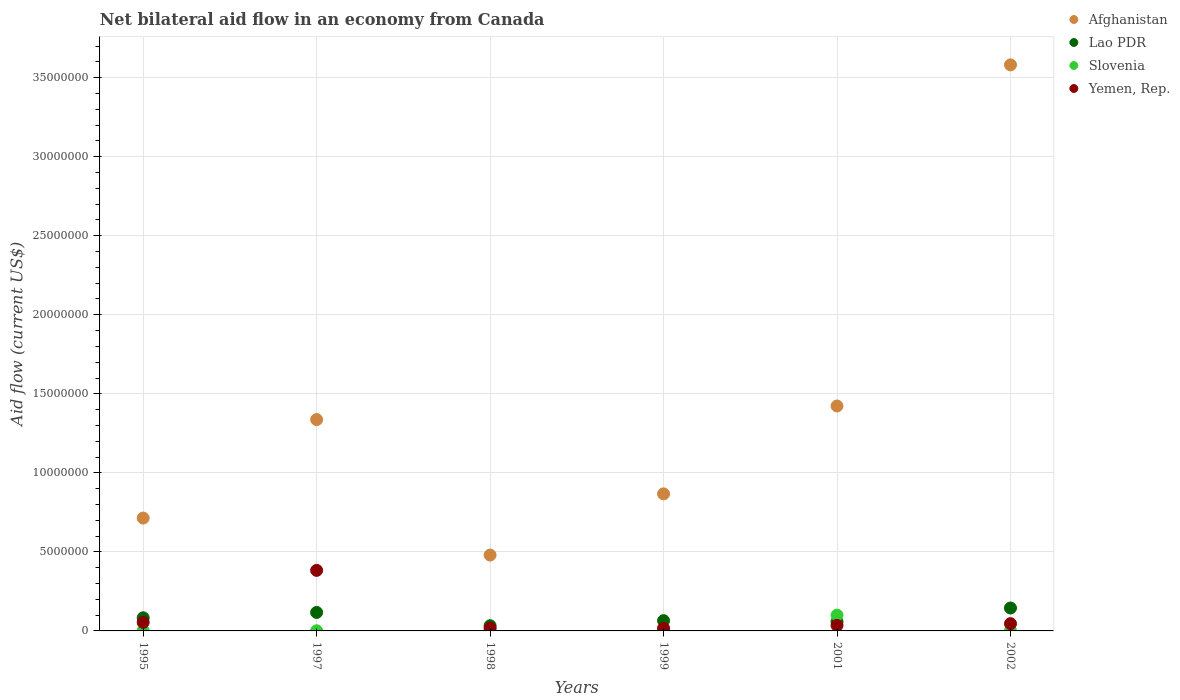How many different coloured dotlines are there?
Give a very brief answer. 4. Is the number of dotlines equal to the number of legend labels?
Your response must be concise. Yes. Across all years, what is the maximum net bilateral aid flow in Yemen, Rep.?
Ensure brevity in your answer.  3.83e+06. What is the total net bilateral aid flow in Afghanistan in the graph?
Offer a terse response. 8.40e+07. What is the difference between the net bilateral aid flow in Lao PDR in 1999 and the net bilateral aid flow in Afghanistan in 2001?
Offer a very short reply. -1.36e+07. What is the average net bilateral aid flow in Lao PDR per year?
Make the answer very short. 8.35e+05. In the year 1997, what is the difference between the net bilateral aid flow in Afghanistan and net bilateral aid flow in Yemen, Rep.?
Ensure brevity in your answer.  9.54e+06. In how many years, is the net bilateral aid flow in Yemen, Rep. greater than 31000000 US$?
Offer a terse response. 0. What is the ratio of the net bilateral aid flow in Lao PDR in 1998 to that in 2002?
Provide a succinct answer. 0.23. Is the net bilateral aid flow in Lao PDR in 1995 less than that in 1999?
Ensure brevity in your answer.  No. Is the difference between the net bilateral aid flow in Afghanistan in 1997 and 1999 greater than the difference between the net bilateral aid flow in Yemen, Rep. in 1997 and 1999?
Your answer should be very brief. Yes. What is the difference between the highest and the second highest net bilateral aid flow in Yemen, Rep.?
Offer a very short reply. 3.29e+06. What is the difference between the highest and the lowest net bilateral aid flow in Yemen, Rep.?
Offer a terse response. 3.66e+06. In how many years, is the net bilateral aid flow in Slovenia greater than the average net bilateral aid flow in Slovenia taken over all years?
Offer a terse response. 1. Is the sum of the net bilateral aid flow in Yemen, Rep. in 1997 and 1998 greater than the maximum net bilateral aid flow in Afghanistan across all years?
Keep it short and to the point. No. Is it the case that in every year, the sum of the net bilateral aid flow in Lao PDR and net bilateral aid flow in Slovenia  is greater than the sum of net bilateral aid flow in Afghanistan and net bilateral aid flow in Yemen, Rep.?
Ensure brevity in your answer.  No. Does the net bilateral aid flow in Yemen, Rep. monotonically increase over the years?
Your answer should be compact. No. Is the net bilateral aid flow in Afghanistan strictly greater than the net bilateral aid flow in Yemen, Rep. over the years?
Your answer should be compact. Yes. Are the values on the major ticks of Y-axis written in scientific E-notation?
Provide a short and direct response. No. Does the graph contain any zero values?
Your response must be concise. No. Does the graph contain grids?
Provide a short and direct response. Yes. Where does the legend appear in the graph?
Keep it short and to the point. Top right. How many legend labels are there?
Make the answer very short. 4. How are the legend labels stacked?
Make the answer very short. Vertical. What is the title of the graph?
Your answer should be compact. Net bilateral aid flow in an economy from Canada. Does "Mexico" appear as one of the legend labels in the graph?
Your response must be concise. No. What is the label or title of the X-axis?
Make the answer very short. Years. What is the label or title of the Y-axis?
Give a very brief answer. Aid flow (current US$). What is the Aid flow (current US$) in Afghanistan in 1995?
Keep it short and to the point. 7.14e+06. What is the Aid flow (current US$) in Lao PDR in 1995?
Provide a succinct answer. 8.30e+05. What is the Aid flow (current US$) in Slovenia in 1995?
Provide a short and direct response. 2.00e+04. What is the Aid flow (current US$) in Yemen, Rep. in 1995?
Ensure brevity in your answer.  5.40e+05. What is the Aid flow (current US$) of Afghanistan in 1997?
Offer a very short reply. 1.34e+07. What is the Aid flow (current US$) in Lao PDR in 1997?
Keep it short and to the point. 1.17e+06. What is the Aid flow (current US$) of Slovenia in 1997?
Make the answer very short. 10000. What is the Aid flow (current US$) in Yemen, Rep. in 1997?
Keep it short and to the point. 3.83e+06. What is the Aid flow (current US$) in Afghanistan in 1998?
Make the answer very short. 4.80e+06. What is the Aid flow (current US$) in Slovenia in 1998?
Your response must be concise. 10000. What is the Aid flow (current US$) of Yemen, Rep. in 1998?
Your response must be concise. 1.80e+05. What is the Aid flow (current US$) in Afghanistan in 1999?
Make the answer very short. 8.67e+06. What is the Aid flow (current US$) in Lao PDR in 1999?
Offer a very short reply. 6.50e+05. What is the Aid flow (current US$) of Slovenia in 1999?
Provide a short and direct response. 2.00e+04. What is the Aid flow (current US$) of Yemen, Rep. in 1999?
Offer a terse response. 1.70e+05. What is the Aid flow (current US$) of Afghanistan in 2001?
Your answer should be very brief. 1.42e+07. What is the Aid flow (current US$) of Lao PDR in 2001?
Keep it short and to the point. 5.80e+05. What is the Aid flow (current US$) of Afghanistan in 2002?
Your response must be concise. 3.58e+07. What is the Aid flow (current US$) in Lao PDR in 2002?
Ensure brevity in your answer.  1.45e+06. What is the Aid flow (current US$) in Slovenia in 2002?
Make the answer very short. 10000. Across all years, what is the maximum Aid flow (current US$) of Afghanistan?
Make the answer very short. 3.58e+07. Across all years, what is the maximum Aid flow (current US$) of Lao PDR?
Make the answer very short. 1.45e+06. Across all years, what is the maximum Aid flow (current US$) in Yemen, Rep.?
Offer a very short reply. 3.83e+06. Across all years, what is the minimum Aid flow (current US$) in Afghanistan?
Offer a very short reply. 4.80e+06. Across all years, what is the minimum Aid flow (current US$) in Lao PDR?
Offer a terse response. 3.30e+05. What is the total Aid flow (current US$) of Afghanistan in the graph?
Your response must be concise. 8.40e+07. What is the total Aid flow (current US$) in Lao PDR in the graph?
Provide a short and direct response. 5.01e+06. What is the total Aid flow (current US$) of Slovenia in the graph?
Provide a succinct answer. 1.07e+06. What is the total Aid flow (current US$) of Yemen, Rep. in the graph?
Make the answer very short. 5.53e+06. What is the difference between the Aid flow (current US$) in Afghanistan in 1995 and that in 1997?
Provide a short and direct response. -6.23e+06. What is the difference between the Aid flow (current US$) of Lao PDR in 1995 and that in 1997?
Your answer should be very brief. -3.40e+05. What is the difference between the Aid flow (current US$) in Slovenia in 1995 and that in 1997?
Your response must be concise. 10000. What is the difference between the Aid flow (current US$) in Yemen, Rep. in 1995 and that in 1997?
Your response must be concise. -3.29e+06. What is the difference between the Aid flow (current US$) of Afghanistan in 1995 and that in 1998?
Your answer should be compact. 2.34e+06. What is the difference between the Aid flow (current US$) of Lao PDR in 1995 and that in 1998?
Provide a short and direct response. 5.00e+05. What is the difference between the Aid flow (current US$) in Slovenia in 1995 and that in 1998?
Provide a succinct answer. 10000. What is the difference between the Aid flow (current US$) in Yemen, Rep. in 1995 and that in 1998?
Ensure brevity in your answer.  3.60e+05. What is the difference between the Aid flow (current US$) of Afghanistan in 1995 and that in 1999?
Your answer should be very brief. -1.53e+06. What is the difference between the Aid flow (current US$) in Slovenia in 1995 and that in 1999?
Offer a very short reply. 0. What is the difference between the Aid flow (current US$) of Afghanistan in 1995 and that in 2001?
Keep it short and to the point. -7.09e+06. What is the difference between the Aid flow (current US$) of Lao PDR in 1995 and that in 2001?
Give a very brief answer. 2.50e+05. What is the difference between the Aid flow (current US$) in Slovenia in 1995 and that in 2001?
Make the answer very short. -9.80e+05. What is the difference between the Aid flow (current US$) of Afghanistan in 1995 and that in 2002?
Offer a terse response. -2.87e+07. What is the difference between the Aid flow (current US$) in Lao PDR in 1995 and that in 2002?
Provide a short and direct response. -6.20e+05. What is the difference between the Aid flow (current US$) in Slovenia in 1995 and that in 2002?
Keep it short and to the point. 10000. What is the difference between the Aid flow (current US$) in Afghanistan in 1997 and that in 1998?
Ensure brevity in your answer.  8.57e+06. What is the difference between the Aid flow (current US$) of Lao PDR in 1997 and that in 1998?
Provide a short and direct response. 8.40e+05. What is the difference between the Aid flow (current US$) of Yemen, Rep. in 1997 and that in 1998?
Offer a very short reply. 3.65e+06. What is the difference between the Aid flow (current US$) of Afghanistan in 1997 and that in 1999?
Offer a terse response. 4.70e+06. What is the difference between the Aid flow (current US$) of Lao PDR in 1997 and that in 1999?
Give a very brief answer. 5.20e+05. What is the difference between the Aid flow (current US$) in Yemen, Rep. in 1997 and that in 1999?
Your answer should be compact. 3.66e+06. What is the difference between the Aid flow (current US$) of Afghanistan in 1997 and that in 2001?
Provide a succinct answer. -8.60e+05. What is the difference between the Aid flow (current US$) of Lao PDR in 1997 and that in 2001?
Ensure brevity in your answer.  5.90e+05. What is the difference between the Aid flow (current US$) of Slovenia in 1997 and that in 2001?
Ensure brevity in your answer.  -9.90e+05. What is the difference between the Aid flow (current US$) of Yemen, Rep. in 1997 and that in 2001?
Ensure brevity in your answer.  3.48e+06. What is the difference between the Aid flow (current US$) of Afghanistan in 1997 and that in 2002?
Offer a very short reply. -2.24e+07. What is the difference between the Aid flow (current US$) of Lao PDR in 1997 and that in 2002?
Ensure brevity in your answer.  -2.80e+05. What is the difference between the Aid flow (current US$) in Yemen, Rep. in 1997 and that in 2002?
Offer a very short reply. 3.37e+06. What is the difference between the Aid flow (current US$) in Afghanistan in 1998 and that in 1999?
Your response must be concise. -3.87e+06. What is the difference between the Aid flow (current US$) in Lao PDR in 1998 and that in 1999?
Give a very brief answer. -3.20e+05. What is the difference between the Aid flow (current US$) of Yemen, Rep. in 1998 and that in 1999?
Your answer should be very brief. 10000. What is the difference between the Aid flow (current US$) in Afghanistan in 1998 and that in 2001?
Offer a very short reply. -9.43e+06. What is the difference between the Aid flow (current US$) of Slovenia in 1998 and that in 2001?
Make the answer very short. -9.90e+05. What is the difference between the Aid flow (current US$) of Afghanistan in 1998 and that in 2002?
Your response must be concise. -3.10e+07. What is the difference between the Aid flow (current US$) in Lao PDR in 1998 and that in 2002?
Your answer should be very brief. -1.12e+06. What is the difference between the Aid flow (current US$) of Yemen, Rep. in 1998 and that in 2002?
Ensure brevity in your answer.  -2.80e+05. What is the difference between the Aid flow (current US$) in Afghanistan in 1999 and that in 2001?
Offer a very short reply. -5.56e+06. What is the difference between the Aid flow (current US$) in Lao PDR in 1999 and that in 2001?
Your answer should be very brief. 7.00e+04. What is the difference between the Aid flow (current US$) of Slovenia in 1999 and that in 2001?
Provide a succinct answer. -9.80e+05. What is the difference between the Aid flow (current US$) in Yemen, Rep. in 1999 and that in 2001?
Ensure brevity in your answer.  -1.80e+05. What is the difference between the Aid flow (current US$) in Afghanistan in 1999 and that in 2002?
Offer a terse response. -2.71e+07. What is the difference between the Aid flow (current US$) in Lao PDR in 1999 and that in 2002?
Keep it short and to the point. -8.00e+05. What is the difference between the Aid flow (current US$) in Afghanistan in 2001 and that in 2002?
Offer a terse response. -2.16e+07. What is the difference between the Aid flow (current US$) of Lao PDR in 2001 and that in 2002?
Offer a terse response. -8.70e+05. What is the difference between the Aid flow (current US$) in Slovenia in 2001 and that in 2002?
Offer a very short reply. 9.90e+05. What is the difference between the Aid flow (current US$) in Afghanistan in 1995 and the Aid flow (current US$) in Lao PDR in 1997?
Provide a short and direct response. 5.97e+06. What is the difference between the Aid flow (current US$) of Afghanistan in 1995 and the Aid flow (current US$) of Slovenia in 1997?
Ensure brevity in your answer.  7.13e+06. What is the difference between the Aid flow (current US$) of Afghanistan in 1995 and the Aid flow (current US$) of Yemen, Rep. in 1997?
Offer a very short reply. 3.31e+06. What is the difference between the Aid flow (current US$) of Lao PDR in 1995 and the Aid flow (current US$) of Slovenia in 1997?
Make the answer very short. 8.20e+05. What is the difference between the Aid flow (current US$) of Slovenia in 1995 and the Aid flow (current US$) of Yemen, Rep. in 1997?
Give a very brief answer. -3.81e+06. What is the difference between the Aid flow (current US$) in Afghanistan in 1995 and the Aid flow (current US$) in Lao PDR in 1998?
Give a very brief answer. 6.81e+06. What is the difference between the Aid flow (current US$) in Afghanistan in 1995 and the Aid flow (current US$) in Slovenia in 1998?
Your answer should be compact. 7.13e+06. What is the difference between the Aid flow (current US$) of Afghanistan in 1995 and the Aid flow (current US$) of Yemen, Rep. in 1998?
Provide a succinct answer. 6.96e+06. What is the difference between the Aid flow (current US$) of Lao PDR in 1995 and the Aid flow (current US$) of Slovenia in 1998?
Your answer should be very brief. 8.20e+05. What is the difference between the Aid flow (current US$) of Lao PDR in 1995 and the Aid flow (current US$) of Yemen, Rep. in 1998?
Your answer should be very brief. 6.50e+05. What is the difference between the Aid flow (current US$) in Slovenia in 1995 and the Aid flow (current US$) in Yemen, Rep. in 1998?
Your answer should be very brief. -1.60e+05. What is the difference between the Aid flow (current US$) of Afghanistan in 1995 and the Aid flow (current US$) of Lao PDR in 1999?
Your answer should be compact. 6.49e+06. What is the difference between the Aid flow (current US$) of Afghanistan in 1995 and the Aid flow (current US$) of Slovenia in 1999?
Your answer should be compact. 7.12e+06. What is the difference between the Aid flow (current US$) of Afghanistan in 1995 and the Aid flow (current US$) of Yemen, Rep. in 1999?
Your response must be concise. 6.97e+06. What is the difference between the Aid flow (current US$) in Lao PDR in 1995 and the Aid flow (current US$) in Slovenia in 1999?
Make the answer very short. 8.10e+05. What is the difference between the Aid flow (current US$) in Lao PDR in 1995 and the Aid flow (current US$) in Yemen, Rep. in 1999?
Provide a succinct answer. 6.60e+05. What is the difference between the Aid flow (current US$) of Slovenia in 1995 and the Aid flow (current US$) of Yemen, Rep. in 1999?
Offer a very short reply. -1.50e+05. What is the difference between the Aid flow (current US$) in Afghanistan in 1995 and the Aid flow (current US$) in Lao PDR in 2001?
Keep it short and to the point. 6.56e+06. What is the difference between the Aid flow (current US$) of Afghanistan in 1995 and the Aid flow (current US$) of Slovenia in 2001?
Your answer should be compact. 6.14e+06. What is the difference between the Aid flow (current US$) of Afghanistan in 1995 and the Aid flow (current US$) of Yemen, Rep. in 2001?
Offer a terse response. 6.79e+06. What is the difference between the Aid flow (current US$) of Slovenia in 1995 and the Aid flow (current US$) of Yemen, Rep. in 2001?
Your answer should be very brief. -3.30e+05. What is the difference between the Aid flow (current US$) of Afghanistan in 1995 and the Aid flow (current US$) of Lao PDR in 2002?
Give a very brief answer. 5.69e+06. What is the difference between the Aid flow (current US$) of Afghanistan in 1995 and the Aid flow (current US$) of Slovenia in 2002?
Your answer should be compact. 7.13e+06. What is the difference between the Aid flow (current US$) of Afghanistan in 1995 and the Aid flow (current US$) of Yemen, Rep. in 2002?
Keep it short and to the point. 6.68e+06. What is the difference between the Aid flow (current US$) in Lao PDR in 1995 and the Aid flow (current US$) in Slovenia in 2002?
Keep it short and to the point. 8.20e+05. What is the difference between the Aid flow (current US$) of Lao PDR in 1995 and the Aid flow (current US$) of Yemen, Rep. in 2002?
Give a very brief answer. 3.70e+05. What is the difference between the Aid flow (current US$) of Slovenia in 1995 and the Aid flow (current US$) of Yemen, Rep. in 2002?
Provide a short and direct response. -4.40e+05. What is the difference between the Aid flow (current US$) of Afghanistan in 1997 and the Aid flow (current US$) of Lao PDR in 1998?
Your answer should be very brief. 1.30e+07. What is the difference between the Aid flow (current US$) of Afghanistan in 1997 and the Aid flow (current US$) of Slovenia in 1998?
Your answer should be compact. 1.34e+07. What is the difference between the Aid flow (current US$) of Afghanistan in 1997 and the Aid flow (current US$) of Yemen, Rep. in 1998?
Offer a very short reply. 1.32e+07. What is the difference between the Aid flow (current US$) of Lao PDR in 1997 and the Aid flow (current US$) of Slovenia in 1998?
Make the answer very short. 1.16e+06. What is the difference between the Aid flow (current US$) in Lao PDR in 1997 and the Aid flow (current US$) in Yemen, Rep. in 1998?
Your answer should be compact. 9.90e+05. What is the difference between the Aid flow (current US$) in Afghanistan in 1997 and the Aid flow (current US$) in Lao PDR in 1999?
Offer a very short reply. 1.27e+07. What is the difference between the Aid flow (current US$) of Afghanistan in 1997 and the Aid flow (current US$) of Slovenia in 1999?
Offer a terse response. 1.34e+07. What is the difference between the Aid flow (current US$) in Afghanistan in 1997 and the Aid flow (current US$) in Yemen, Rep. in 1999?
Your answer should be compact. 1.32e+07. What is the difference between the Aid flow (current US$) in Lao PDR in 1997 and the Aid flow (current US$) in Slovenia in 1999?
Ensure brevity in your answer.  1.15e+06. What is the difference between the Aid flow (current US$) in Lao PDR in 1997 and the Aid flow (current US$) in Yemen, Rep. in 1999?
Make the answer very short. 1.00e+06. What is the difference between the Aid flow (current US$) in Slovenia in 1997 and the Aid flow (current US$) in Yemen, Rep. in 1999?
Give a very brief answer. -1.60e+05. What is the difference between the Aid flow (current US$) in Afghanistan in 1997 and the Aid flow (current US$) in Lao PDR in 2001?
Your response must be concise. 1.28e+07. What is the difference between the Aid flow (current US$) in Afghanistan in 1997 and the Aid flow (current US$) in Slovenia in 2001?
Give a very brief answer. 1.24e+07. What is the difference between the Aid flow (current US$) of Afghanistan in 1997 and the Aid flow (current US$) of Yemen, Rep. in 2001?
Provide a succinct answer. 1.30e+07. What is the difference between the Aid flow (current US$) in Lao PDR in 1997 and the Aid flow (current US$) in Yemen, Rep. in 2001?
Ensure brevity in your answer.  8.20e+05. What is the difference between the Aid flow (current US$) in Afghanistan in 1997 and the Aid flow (current US$) in Lao PDR in 2002?
Provide a short and direct response. 1.19e+07. What is the difference between the Aid flow (current US$) of Afghanistan in 1997 and the Aid flow (current US$) of Slovenia in 2002?
Provide a succinct answer. 1.34e+07. What is the difference between the Aid flow (current US$) of Afghanistan in 1997 and the Aid flow (current US$) of Yemen, Rep. in 2002?
Make the answer very short. 1.29e+07. What is the difference between the Aid flow (current US$) in Lao PDR in 1997 and the Aid flow (current US$) in Slovenia in 2002?
Keep it short and to the point. 1.16e+06. What is the difference between the Aid flow (current US$) of Lao PDR in 1997 and the Aid flow (current US$) of Yemen, Rep. in 2002?
Offer a terse response. 7.10e+05. What is the difference between the Aid flow (current US$) of Slovenia in 1997 and the Aid flow (current US$) of Yemen, Rep. in 2002?
Your answer should be very brief. -4.50e+05. What is the difference between the Aid flow (current US$) of Afghanistan in 1998 and the Aid flow (current US$) of Lao PDR in 1999?
Your response must be concise. 4.15e+06. What is the difference between the Aid flow (current US$) of Afghanistan in 1998 and the Aid flow (current US$) of Slovenia in 1999?
Offer a very short reply. 4.78e+06. What is the difference between the Aid flow (current US$) in Afghanistan in 1998 and the Aid flow (current US$) in Yemen, Rep. in 1999?
Your answer should be very brief. 4.63e+06. What is the difference between the Aid flow (current US$) in Lao PDR in 1998 and the Aid flow (current US$) in Yemen, Rep. in 1999?
Make the answer very short. 1.60e+05. What is the difference between the Aid flow (current US$) of Slovenia in 1998 and the Aid flow (current US$) of Yemen, Rep. in 1999?
Your answer should be very brief. -1.60e+05. What is the difference between the Aid flow (current US$) in Afghanistan in 1998 and the Aid flow (current US$) in Lao PDR in 2001?
Your answer should be very brief. 4.22e+06. What is the difference between the Aid flow (current US$) of Afghanistan in 1998 and the Aid flow (current US$) of Slovenia in 2001?
Give a very brief answer. 3.80e+06. What is the difference between the Aid flow (current US$) in Afghanistan in 1998 and the Aid flow (current US$) in Yemen, Rep. in 2001?
Provide a short and direct response. 4.45e+06. What is the difference between the Aid flow (current US$) of Lao PDR in 1998 and the Aid flow (current US$) of Slovenia in 2001?
Provide a short and direct response. -6.70e+05. What is the difference between the Aid flow (current US$) of Afghanistan in 1998 and the Aid flow (current US$) of Lao PDR in 2002?
Make the answer very short. 3.35e+06. What is the difference between the Aid flow (current US$) of Afghanistan in 1998 and the Aid flow (current US$) of Slovenia in 2002?
Your answer should be compact. 4.79e+06. What is the difference between the Aid flow (current US$) of Afghanistan in 1998 and the Aid flow (current US$) of Yemen, Rep. in 2002?
Your answer should be compact. 4.34e+06. What is the difference between the Aid flow (current US$) of Lao PDR in 1998 and the Aid flow (current US$) of Slovenia in 2002?
Your answer should be compact. 3.20e+05. What is the difference between the Aid flow (current US$) in Slovenia in 1998 and the Aid flow (current US$) in Yemen, Rep. in 2002?
Offer a terse response. -4.50e+05. What is the difference between the Aid flow (current US$) in Afghanistan in 1999 and the Aid flow (current US$) in Lao PDR in 2001?
Your answer should be compact. 8.09e+06. What is the difference between the Aid flow (current US$) of Afghanistan in 1999 and the Aid flow (current US$) of Slovenia in 2001?
Offer a terse response. 7.67e+06. What is the difference between the Aid flow (current US$) of Afghanistan in 1999 and the Aid flow (current US$) of Yemen, Rep. in 2001?
Provide a short and direct response. 8.32e+06. What is the difference between the Aid flow (current US$) of Lao PDR in 1999 and the Aid flow (current US$) of Slovenia in 2001?
Your response must be concise. -3.50e+05. What is the difference between the Aid flow (current US$) of Lao PDR in 1999 and the Aid flow (current US$) of Yemen, Rep. in 2001?
Ensure brevity in your answer.  3.00e+05. What is the difference between the Aid flow (current US$) in Slovenia in 1999 and the Aid flow (current US$) in Yemen, Rep. in 2001?
Provide a succinct answer. -3.30e+05. What is the difference between the Aid flow (current US$) in Afghanistan in 1999 and the Aid flow (current US$) in Lao PDR in 2002?
Your answer should be very brief. 7.22e+06. What is the difference between the Aid flow (current US$) of Afghanistan in 1999 and the Aid flow (current US$) of Slovenia in 2002?
Offer a very short reply. 8.66e+06. What is the difference between the Aid flow (current US$) of Afghanistan in 1999 and the Aid flow (current US$) of Yemen, Rep. in 2002?
Keep it short and to the point. 8.21e+06. What is the difference between the Aid flow (current US$) in Lao PDR in 1999 and the Aid flow (current US$) in Slovenia in 2002?
Provide a short and direct response. 6.40e+05. What is the difference between the Aid flow (current US$) in Lao PDR in 1999 and the Aid flow (current US$) in Yemen, Rep. in 2002?
Provide a short and direct response. 1.90e+05. What is the difference between the Aid flow (current US$) of Slovenia in 1999 and the Aid flow (current US$) of Yemen, Rep. in 2002?
Give a very brief answer. -4.40e+05. What is the difference between the Aid flow (current US$) of Afghanistan in 2001 and the Aid flow (current US$) of Lao PDR in 2002?
Offer a terse response. 1.28e+07. What is the difference between the Aid flow (current US$) in Afghanistan in 2001 and the Aid flow (current US$) in Slovenia in 2002?
Offer a very short reply. 1.42e+07. What is the difference between the Aid flow (current US$) of Afghanistan in 2001 and the Aid flow (current US$) of Yemen, Rep. in 2002?
Keep it short and to the point. 1.38e+07. What is the difference between the Aid flow (current US$) in Lao PDR in 2001 and the Aid flow (current US$) in Slovenia in 2002?
Give a very brief answer. 5.70e+05. What is the difference between the Aid flow (current US$) of Slovenia in 2001 and the Aid flow (current US$) of Yemen, Rep. in 2002?
Make the answer very short. 5.40e+05. What is the average Aid flow (current US$) in Afghanistan per year?
Your answer should be very brief. 1.40e+07. What is the average Aid flow (current US$) of Lao PDR per year?
Keep it short and to the point. 8.35e+05. What is the average Aid flow (current US$) in Slovenia per year?
Your answer should be compact. 1.78e+05. What is the average Aid flow (current US$) in Yemen, Rep. per year?
Your answer should be compact. 9.22e+05. In the year 1995, what is the difference between the Aid flow (current US$) of Afghanistan and Aid flow (current US$) of Lao PDR?
Your answer should be very brief. 6.31e+06. In the year 1995, what is the difference between the Aid flow (current US$) in Afghanistan and Aid flow (current US$) in Slovenia?
Offer a very short reply. 7.12e+06. In the year 1995, what is the difference between the Aid flow (current US$) in Afghanistan and Aid flow (current US$) in Yemen, Rep.?
Offer a very short reply. 6.60e+06. In the year 1995, what is the difference between the Aid flow (current US$) in Lao PDR and Aid flow (current US$) in Slovenia?
Provide a short and direct response. 8.10e+05. In the year 1995, what is the difference between the Aid flow (current US$) in Lao PDR and Aid flow (current US$) in Yemen, Rep.?
Keep it short and to the point. 2.90e+05. In the year 1995, what is the difference between the Aid flow (current US$) in Slovenia and Aid flow (current US$) in Yemen, Rep.?
Provide a succinct answer. -5.20e+05. In the year 1997, what is the difference between the Aid flow (current US$) of Afghanistan and Aid flow (current US$) of Lao PDR?
Offer a very short reply. 1.22e+07. In the year 1997, what is the difference between the Aid flow (current US$) of Afghanistan and Aid flow (current US$) of Slovenia?
Make the answer very short. 1.34e+07. In the year 1997, what is the difference between the Aid flow (current US$) in Afghanistan and Aid flow (current US$) in Yemen, Rep.?
Your response must be concise. 9.54e+06. In the year 1997, what is the difference between the Aid flow (current US$) in Lao PDR and Aid flow (current US$) in Slovenia?
Make the answer very short. 1.16e+06. In the year 1997, what is the difference between the Aid flow (current US$) of Lao PDR and Aid flow (current US$) of Yemen, Rep.?
Offer a terse response. -2.66e+06. In the year 1997, what is the difference between the Aid flow (current US$) of Slovenia and Aid flow (current US$) of Yemen, Rep.?
Your answer should be compact. -3.82e+06. In the year 1998, what is the difference between the Aid flow (current US$) in Afghanistan and Aid flow (current US$) in Lao PDR?
Keep it short and to the point. 4.47e+06. In the year 1998, what is the difference between the Aid flow (current US$) of Afghanistan and Aid flow (current US$) of Slovenia?
Your answer should be compact. 4.79e+06. In the year 1998, what is the difference between the Aid flow (current US$) of Afghanistan and Aid flow (current US$) of Yemen, Rep.?
Give a very brief answer. 4.62e+06. In the year 1998, what is the difference between the Aid flow (current US$) of Lao PDR and Aid flow (current US$) of Yemen, Rep.?
Make the answer very short. 1.50e+05. In the year 1999, what is the difference between the Aid flow (current US$) in Afghanistan and Aid flow (current US$) in Lao PDR?
Your answer should be compact. 8.02e+06. In the year 1999, what is the difference between the Aid flow (current US$) of Afghanistan and Aid flow (current US$) of Slovenia?
Provide a short and direct response. 8.65e+06. In the year 1999, what is the difference between the Aid flow (current US$) in Afghanistan and Aid flow (current US$) in Yemen, Rep.?
Keep it short and to the point. 8.50e+06. In the year 1999, what is the difference between the Aid flow (current US$) of Lao PDR and Aid flow (current US$) of Slovenia?
Your answer should be very brief. 6.30e+05. In the year 1999, what is the difference between the Aid flow (current US$) of Lao PDR and Aid flow (current US$) of Yemen, Rep.?
Your answer should be compact. 4.80e+05. In the year 2001, what is the difference between the Aid flow (current US$) in Afghanistan and Aid flow (current US$) in Lao PDR?
Offer a very short reply. 1.36e+07. In the year 2001, what is the difference between the Aid flow (current US$) of Afghanistan and Aid flow (current US$) of Slovenia?
Offer a terse response. 1.32e+07. In the year 2001, what is the difference between the Aid flow (current US$) in Afghanistan and Aid flow (current US$) in Yemen, Rep.?
Offer a very short reply. 1.39e+07. In the year 2001, what is the difference between the Aid flow (current US$) in Lao PDR and Aid flow (current US$) in Slovenia?
Keep it short and to the point. -4.20e+05. In the year 2001, what is the difference between the Aid flow (current US$) in Lao PDR and Aid flow (current US$) in Yemen, Rep.?
Offer a very short reply. 2.30e+05. In the year 2001, what is the difference between the Aid flow (current US$) of Slovenia and Aid flow (current US$) of Yemen, Rep.?
Make the answer very short. 6.50e+05. In the year 2002, what is the difference between the Aid flow (current US$) of Afghanistan and Aid flow (current US$) of Lao PDR?
Your answer should be very brief. 3.44e+07. In the year 2002, what is the difference between the Aid flow (current US$) in Afghanistan and Aid flow (current US$) in Slovenia?
Give a very brief answer. 3.58e+07. In the year 2002, what is the difference between the Aid flow (current US$) in Afghanistan and Aid flow (current US$) in Yemen, Rep.?
Offer a terse response. 3.54e+07. In the year 2002, what is the difference between the Aid flow (current US$) in Lao PDR and Aid flow (current US$) in Slovenia?
Give a very brief answer. 1.44e+06. In the year 2002, what is the difference between the Aid flow (current US$) of Lao PDR and Aid flow (current US$) of Yemen, Rep.?
Provide a succinct answer. 9.90e+05. In the year 2002, what is the difference between the Aid flow (current US$) in Slovenia and Aid flow (current US$) in Yemen, Rep.?
Ensure brevity in your answer.  -4.50e+05. What is the ratio of the Aid flow (current US$) of Afghanistan in 1995 to that in 1997?
Offer a terse response. 0.53. What is the ratio of the Aid flow (current US$) of Lao PDR in 1995 to that in 1997?
Offer a very short reply. 0.71. What is the ratio of the Aid flow (current US$) of Yemen, Rep. in 1995 to that in 1997?
Keep it short and to the point. 0.14. What is the ratio of the Aid flow (current US$) of Afghanistan in 1995 to that in 1998?
Your answer should be compact. 1.49. What is the ratio of the Aid flow (current US$) in Lao PDR in 1995 to that in 1998?
Your response must be concise. 2.52. What is the ratio of the Aid flow (current US$) in Afghanistan in 1995 to that in 1999?
Make the answer very short. 0.82. What is the ratio of the Aid flow (current US$) in Lao PDR in 1995 to that in 1999?
Your answer should be compact. 1.28. What is the ratio of the Aid flow (current US$) of Yemen, Rep. in 1995 to that in 1999?
Your response must be concise. 3.18. What is the ratio of the Aid flow (current US$) in Afghanistan in 1995 to that in 2001?
Provide a short and direct response. 0.5. What is the ratio of the Aid flow (current US$) in Lao PDR in 1995 to that in 2001?
Provide a short and direct response. 1.43. What is the ratio of the Aid flow (current US$) of Slovenia in 1995 to that in 2001?
Offer a very short reply. 0.02. What is the ratio of the Aid flow (current US$) of Yemen, Rep. in 1995 to that in 2001?
Give a very brief answer. 1.54. What is the ratio of the Aid flow (current US$) in Afghanistan in 1995 to that in 2002?
Make the answer very short. 0.2. What is the ratio of the Aid flow (current US$) in Lao PDR in 1995 to that in 2002?
Give a very brief answer. 0.57. What is the ratio of the Aid flow (current US$) in Slovenia in 1995 to that in 2002?
Your answer should be compact. 2. What is the ratio of the Aid flow (current US$) of Yemen, Rep. in 1995 to that in 2002?
Your answer should be compact. 1.17. What is the ratio of the Aid flow (current US$) in Afghanistan in 1997 to that in 1998?
Ensure brevity in your answer.  2.79. What is the ratio of the Aid flow (current US$) of Lao PDR in 1997 to that in 1998?
Provide a succinct answer. 3.55. What is the ratio of the Aid flow (current US$) of Yemen, Rep. in 1997 to that in 1998?
Provide a short and direct response. 21.28. What is the ratio of the Aid flow (current US$) of Afghanistan in 1997 to that in 1999?
Ensure brevity in your answer.  1.54. What is the ratio of the Aid flow (current US$) of Lao PDR in 1997 to that in 1999?
Provide a succinct answer. 1.8. What is the ratio of the Aid flow (current US$) in Yemen, Rep. in 1997 to that in 1999?
Your answer should be very brief. 22.53. What is the ratio of the Aid flow (current US$) in Afghanistan in 1997 to that in 2001?
Offer a terse response. 0.94. What is the ratio of the Aid flow (current US$) in Lao PDR in 1997 to that in 2001?
Your answer should be very brief. 2.02. What is the ratio of the Aid flow (current US$) in Yemen, Rep. in 1997 to that in 2001?
Your answer should be very brief. 10.94. What is the ratio of the Aid flow (current US$) of Afghanistan in 1997 to that in 2002?
Provide a succinct answer. 0.37. What is the ratio of the Aid flow (current US$) of Lao PDR in 1997 to that in 2002?
Offer a very short reply. 0.81. What is the ratio of the Aid flow (current US$) in Yemen, Rep. in 1997 to that in 2002?
Keep it short and to the point. 8.33. What is the ratio of the Aid flow (current US$) of Afghanistan in 1998 to that in 1999?
Your response must be concise. 0.55. What is the ratio of the Aid flow (current US$) of Lao PDR in 1998 to that in 1999?
Your answer should be very brief. 0.51. What is the ratio of the Aid flow (current US$) of Yemen, Rep. in 1998 to that in 1999?
Offer a very short reply. 1.06. What is the ratio of the Aid flow (current US$) in Afghanistan in 1998 to that in 2001?
Your answer should be compact. 0.34. What is the ratio of the Aid flow (current US$) in Lao PDR in 1998 to that in 2001?
Your response must be concise. 0.57. What is the ratio of the Aid flow (current US$) in Yemen, Rep. in 1998 to that in 2001?
Your response must be concise. 0.51. What is the ratio of the Aid flow (current US$) in Afghanistan in 1998 to that in 2002?
Provide a succinct answer. 0.13. What is the ratio of the Aid flow (current US$) in Lao PDR in 1998 to that in 2002?
Your answer should be compact. 0.23. What is the ratio of the Aid flow (current US$) of Yemen, Rep. in 1998 to that in 2002?
Your answer should be compact. 0.39. What is the ratio of the Aid flow (current US$) in Afghanistan in 1999 to that in 2001?
Offer a terse response. 0.61. What is the ratio of the Aid flow (current US$) of Lao PDR in 1999 to that in 2001?
Provide a short and direct response. 1.12. What is the ratio of the Aid flow (current US$) in Yemen, Rep. in 1999 to that in 2001?
Keep it short and to the point. 0.49. What is the ratio of the Aid flow (current US$) in Afghanistan in 1999 to that in 2002?
Your response must be concise. 0.24. What is the ratio of the Aid flow (current US$) in Lao PDR in 1999 to that in 2002?
Offer a very short reply. 0.45. What is the ratio of the Aid flow (current US$) of Slovenia in 1999 to that in 2002?
Your response must be concise. 2. What is the ratio of the Aid flow (current US$) in Yemen, Rep. in 1999 to that in 2002?
Give a very brief answer. 0.37. What is the ratio of the Aid flow (current US$) in Afghanistan in 2001 to that in 2002?
Give a very brief answer. 0.4. What is the ratio of the Aid flow (current US$) of Lao PDR in 2001 to that in 2002?
Your response must be concise. 0.4. What is the ratio of the Aid flow (current US$) of Yemen, Rep. in 2001 to that in 2002?
Offer a very short reply. 0.76. What is the difference between the highest and the second highest Aid flow (current US$) in Afghanistan?
Offer a terse response. 2.16e+07. What is the difference between the highest and the second highest Aid flow (current US$) of Slovenia?
Provide a succinct answer. 9.80e+05. What is the difference between the highest and the second highest Aid flow (current US$) in Yemen, Rep.?
Your response must be concise. 3.29e+06. What is the difference between the highest and the lowest Aid flow (current US$) in Afghanistan?
Ensure brevity in your answer.  3.10e+07. What is the difference between the highest and the lowest Aid flow (current US$) in Lao PDR?
Offer a terse response. 1.12e+06. What is the difference between the highest and the lowest Aid flow (current US$) in Slovenia?
Your answer should be compact. 9.90e+05. What is the difference between the highest and the lowest Aid flow (current US$) of Yemen, Rep.?
Offer a very short reply. 3.66e+06. 